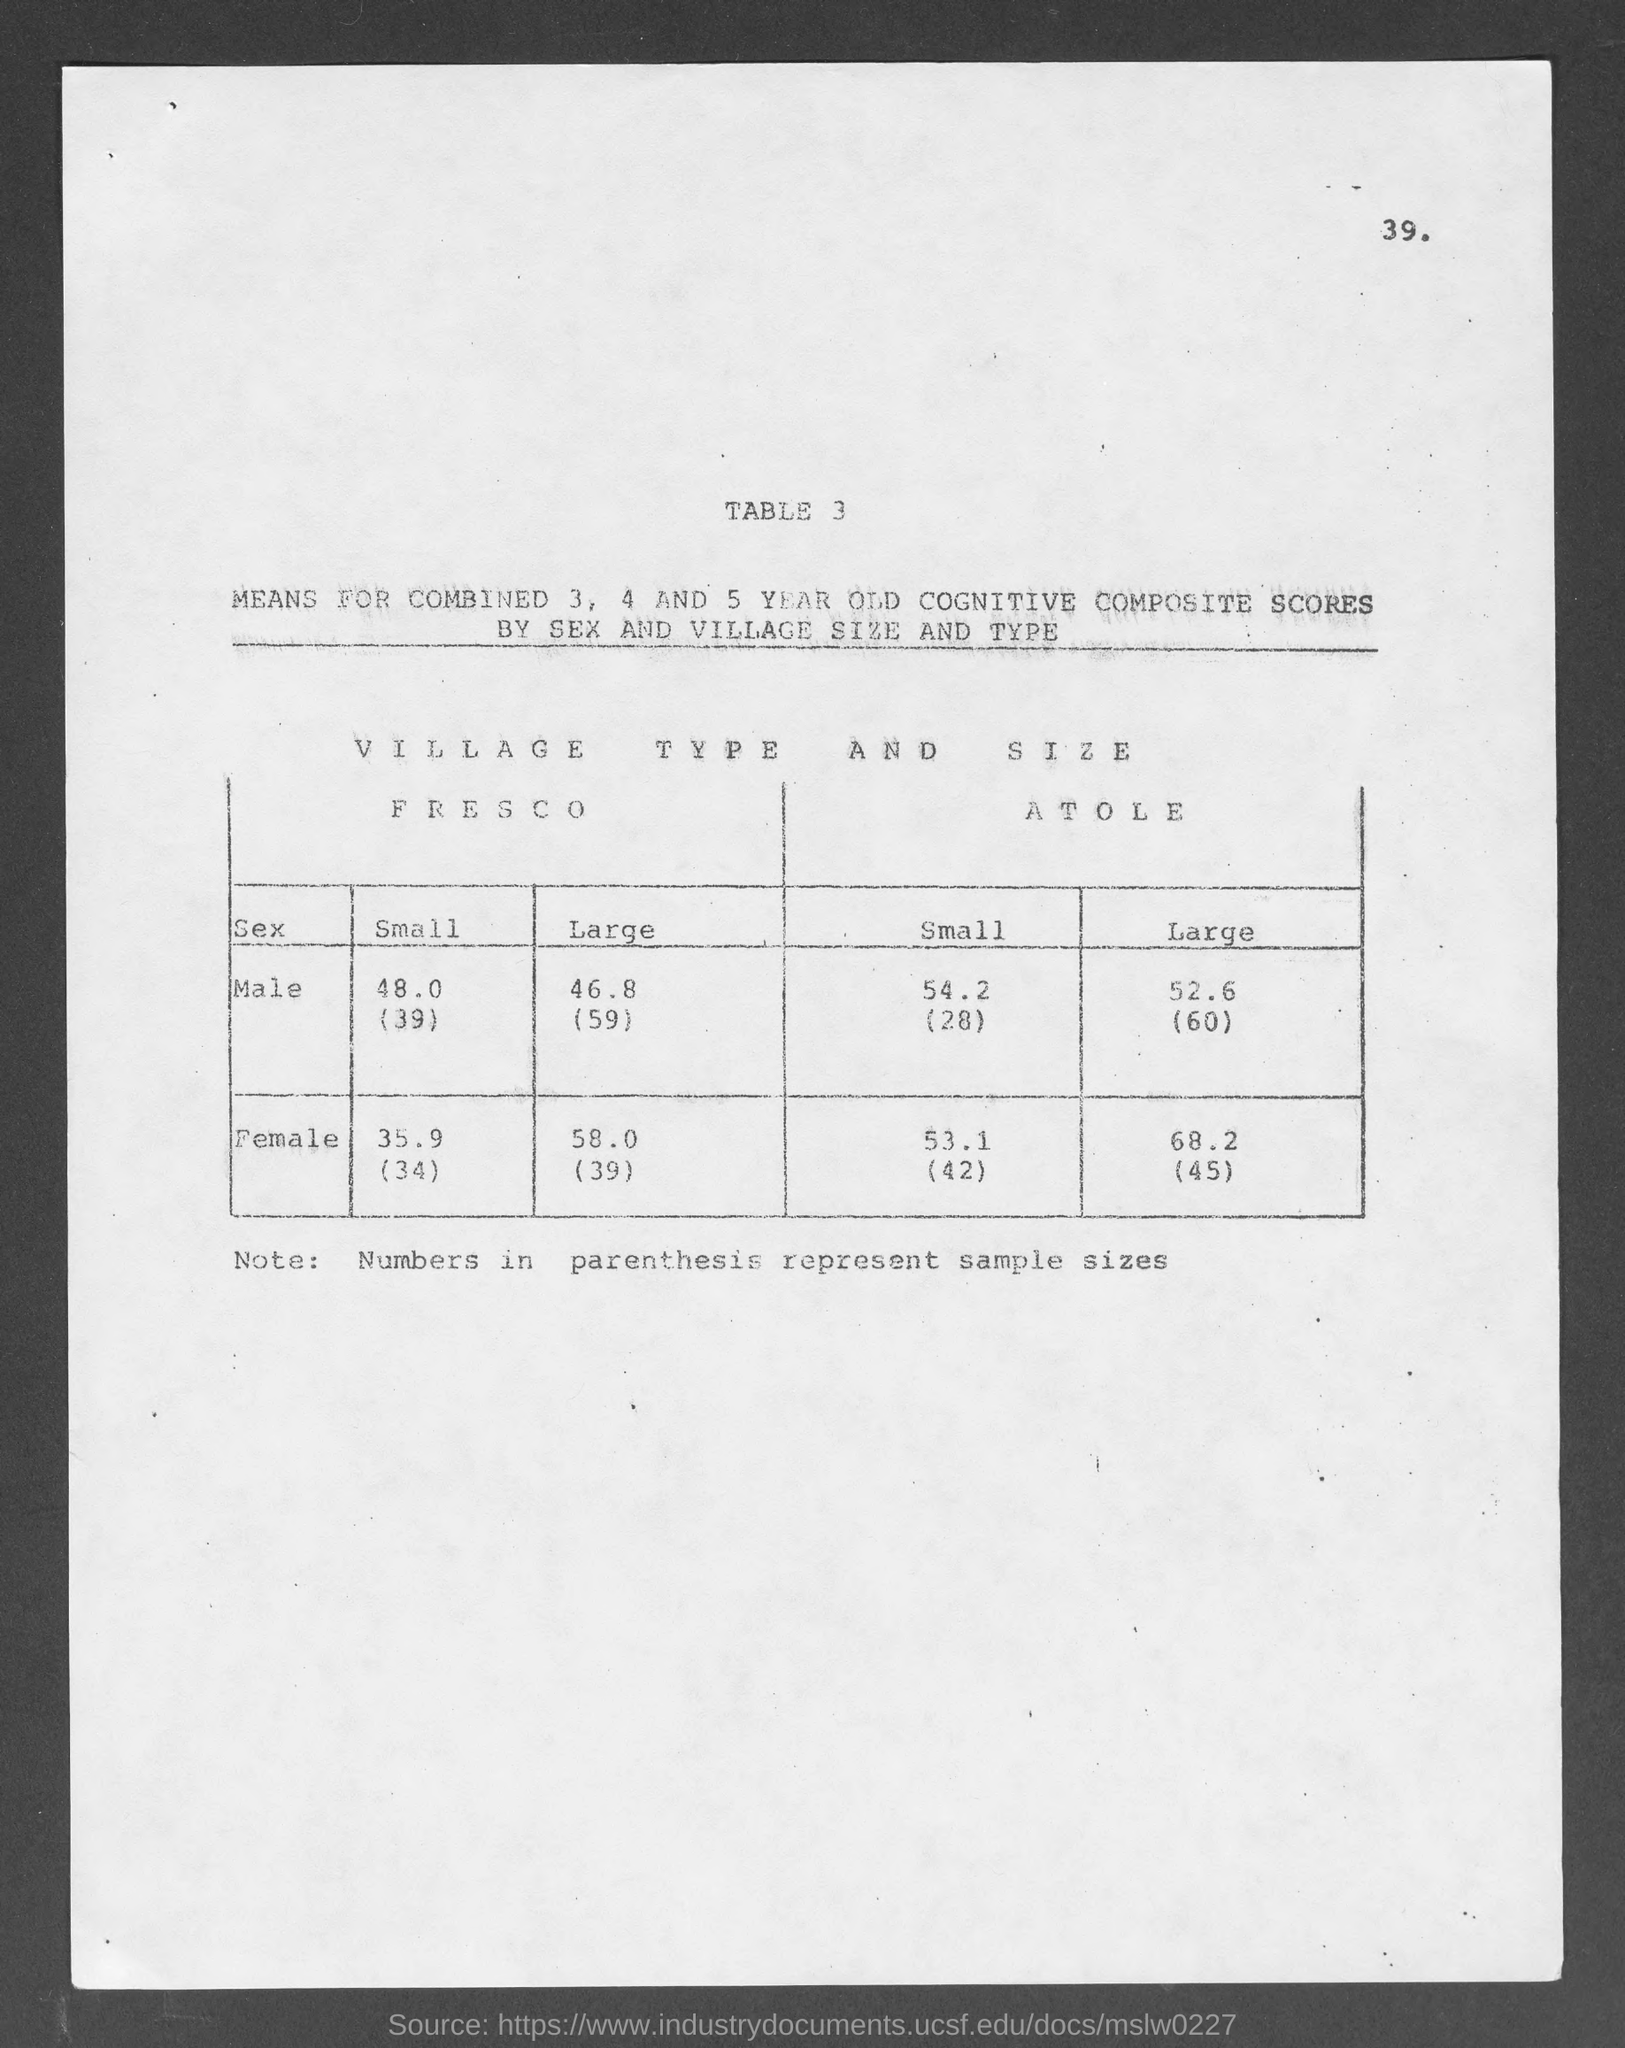Outline some significant characteristics in this image. The note mentioned in the given page includes numbers in parentheses representing sample sizes. The value of small size for males in Fresco, as listed in the provided table, is 48.0 inches (39 inches). According to the given table, the large size for male is 52.6 inches. According to the given table, the value of small size for female in Fresco is 35.9(34). The given table mentions the value of "small size for female" as 53.1. 